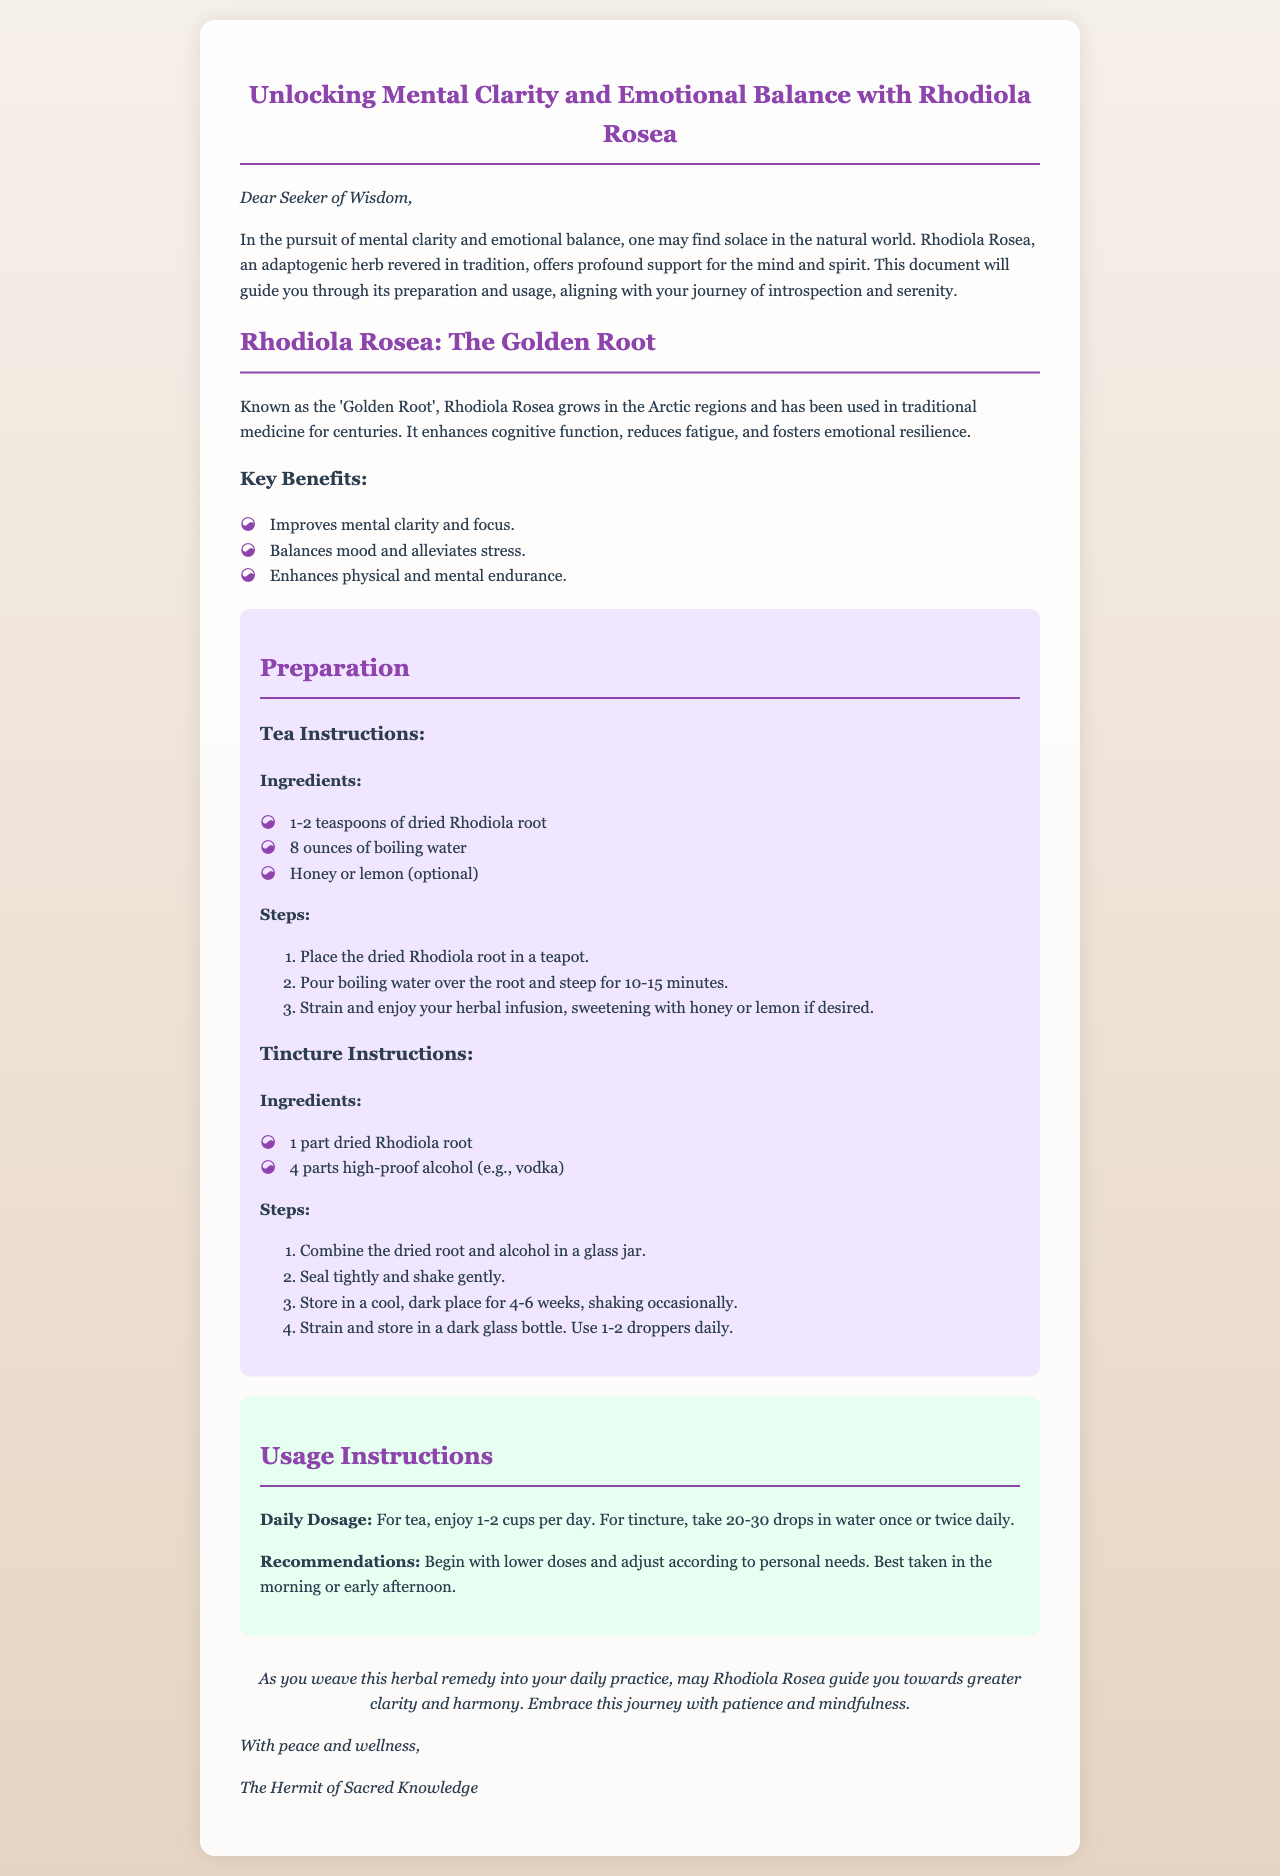What is the main ingredient discussed in the document? The document is primarily focused on the herbal remedy Rhodiola Rosea.
Answer: Rhodiola Rosea How many teaspoons of dried Rhodiola root are needed for the tea? The tea preparation instructions specify using 1-2 teaspoons of dried Rhodiola root.
Answer: 1-2 teaspoons How long should the tincture be stored before use? The tincture instructions recommend storing it for 4-6 weeks.
Answer: 4-6 weeks What is the daily dosage for tincture? The usage instructions state to take 20-30 drops in water once or twice daily.
Answer: 20-30 drops What is one recommended time to take the herbal remedy? The document suggests that the remedy is best taken in the morning or early afternoon.
Answer: Morning or early afternoon Who is the author of the document? The document is signed by "The Hermit of Sacred Knowledge."
Answer: The Hermit of Sacred Knowledge What is the color of the background in the document? The background is described as a linear gradient from light to darker hues.
Answer: Gradient from light to dark What type of document is this based on its structure? The structure of the document resembles an informative email about a herbal remedy.
Answer: Informative email 